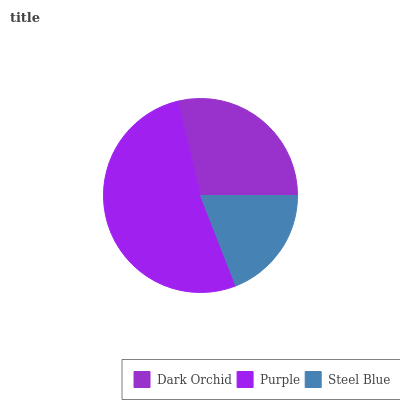Is Steel Blue the minimum?
Answer yes or no. Yes. Is Purple the maximum?
Answer yes or no. Yes. Is Purple the minimum?
Answer yes or no. No. Is Steel Blue the maximum?
Answer yes or no. No. Is Purple greater than Steel Blue?
Answer yes or no. Yes. Is Steel Blue less than Purple?
Answer yes or no. Yes. Is Steel Blue greater than Purple?
Answer yes or no. No. Is Purple less than Steel Blue?
Answer yes or no. No. Is Dark Orchid the high median?
Answer yes or no. Yes. Is Dark Orchid the low median?
Answer yes or no. Yes. Is Purple the high median?
Answer yes or no. No. Is Steel Blue the low median?
Answer yes or no. No. 